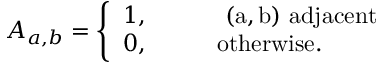Convert formula to latex. <formula><loc_0><loc_0><loc_500><loc_500>A _ { a , b } = \left \{ \begin{array} { l l } { 1 , \quad } & { ( a , b ) a d j a c e n t } \\ { 0 , \quad } & { o t h e r w i s e . } \end{array}</formula> 